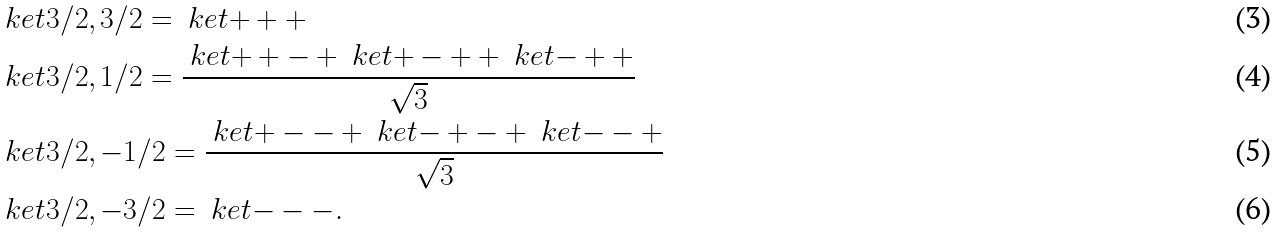<formula> <loc_0><loc_0><loc_500><loc_500>& \ k e t { 3 / 2 , 3 / 2 } = \ k e t { + + + } \\ & \ k e t { 3 / 2 , 1 / 2 } = \frac { \ k e t { + + - } + \ k e t { + - + } + \ k e t { - + + } } { \sqrt { 3 } } \\ & \ k e t { 3 / 2 , - 1 / 2 } = \frac { \ k e t { + - - } + \ k e t { - + - } + \ k e t { - - + } } { \sqrt { 3 } } \\ & \ k e t { 3 / 2 , - 3 / 2 } = \ k e t { - - - } .</formula> 